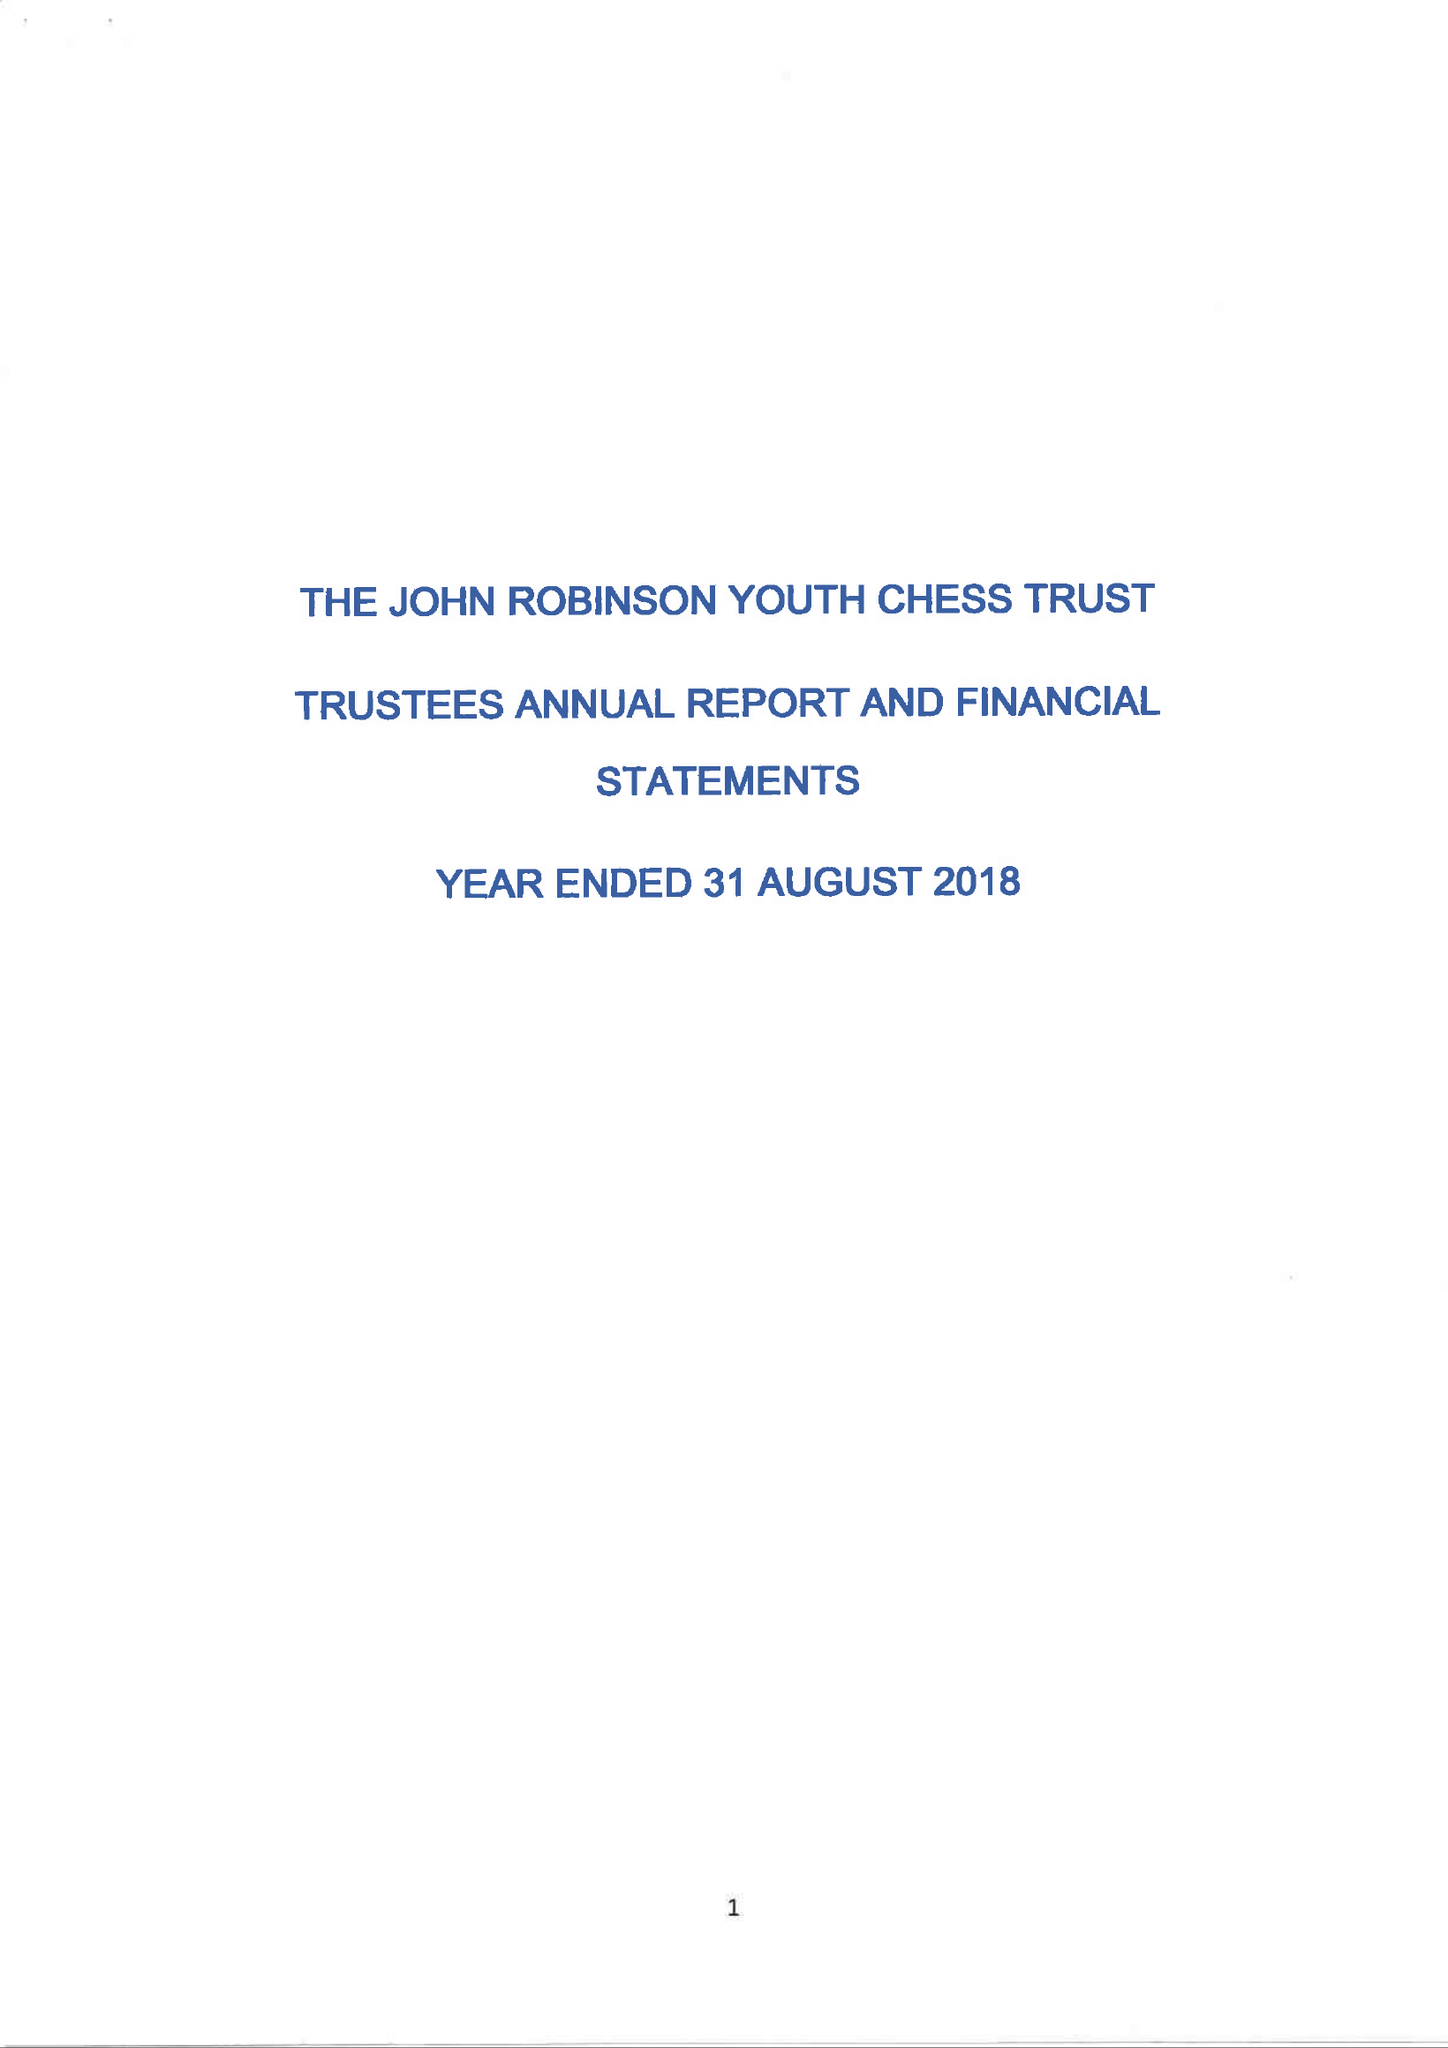What is the value for the address__street_line?
Answer the question using a single word or phrase. 6 MAYFIELD 